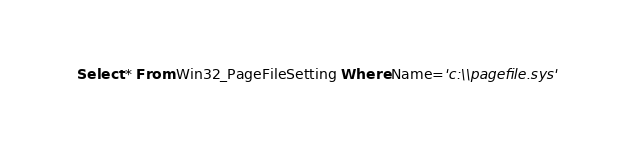<code> <loc_0><loc_0><loc_500><loc_500><_SQL_>Select * From Win32_PageFileSetting Where Name='c:\\pagefile.sys'
</code> 